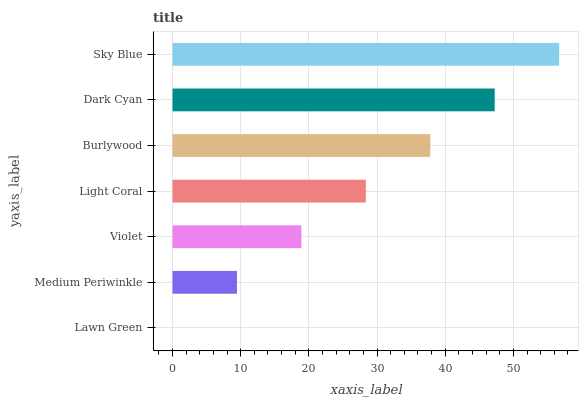Is Lawn Green the minimum?
Answer yes or no. Yes. Is Sky Blue the maximum?
Answer yes or no. Yes. Is Medium Periwinkle the minimum?
Answer yes or no. No. Is Medium Periwinkle the maximum?
Answer yes or no. No. Is Medium Periwinkle greater than Lawn Green?
Answer yes or no. Yes. Is Lawn Green less than Medium Periwinkle?
Answer yes or no. Yes. Is Lawn Green greater than Medium Periwinkle?
Answer yes or no. No. Is Medium Periwinkle less than Lawn Green?
Answer yes or no. No. Is Light Coral the high median?
Answer yes or no. Yes. Is Light Coral the low median?
Answer yes or no. Yes. Is Burlywood the high median?
Answer yes or no. No. Is Lawn Green the low median?
Answer yes or no. No. 